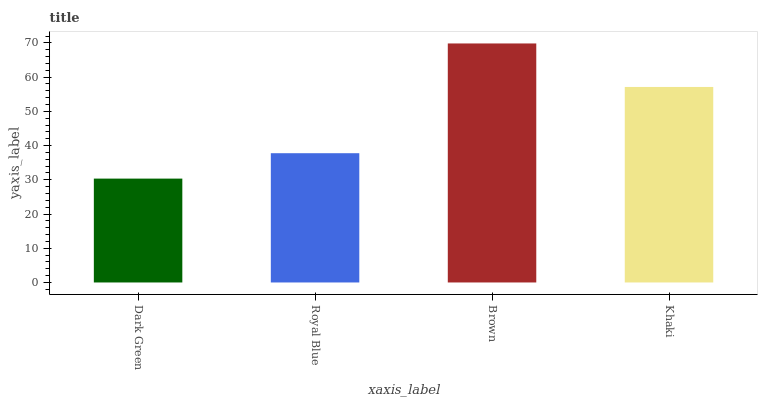Is Royal Blue the minimum?
Answer yes or no. No. Is Royal Blue the maximum?
Answer yes or no. No. Is Royal Blue greater than Dark Green?
Answer yes or no. Yes. Is Dark Green less than Royal Blue?
Answer yes or no. Yes. Is Dark Green greater than Royal Blue?
Answer yes or no. No. Is Royal Blue less than Dark Green?
Answer yes or no. No. Is Khaki the high median?
Answer yes or no. Yes. Is Royal Blue the low median?
Answer yes or no. Yes. Is Dark Green the high median?
Answer yes or no. No. Is Brown the low median?
Answer yes or no. No. 